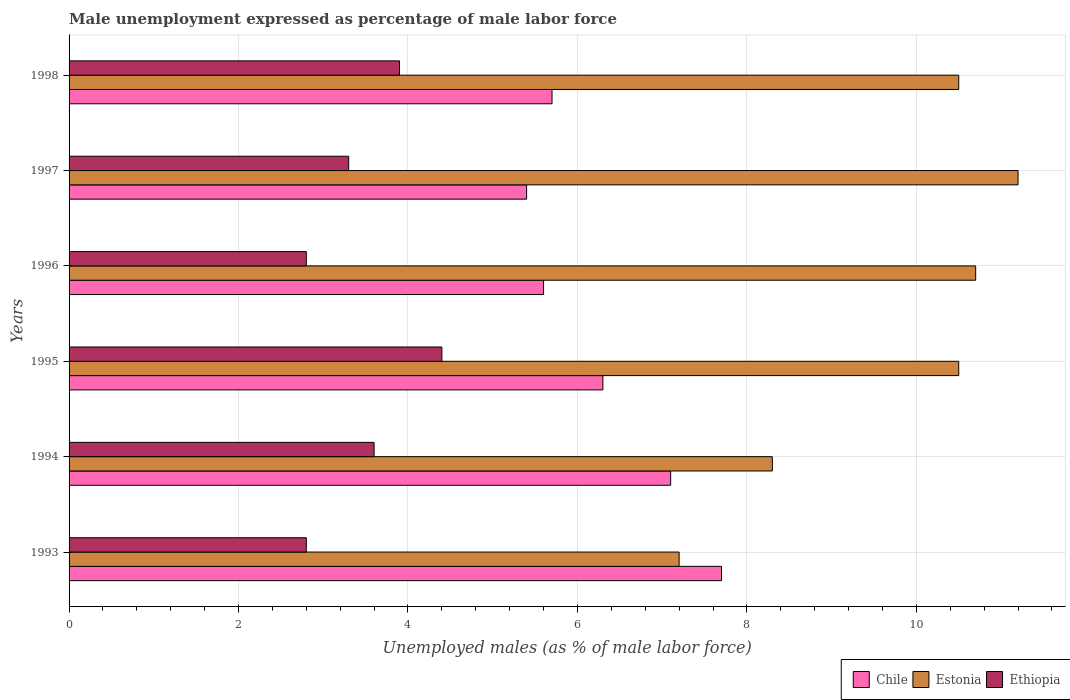How many groups of bars are there?
Your answer should be very brief. 6. Are the number of bars per tick equal to the number of legend labels?
Your answer should be compact. Yes. What is the label of the 1st group of bars from the top?
Provide a short and direct response. 1998. What is the unemployment in males in in Ethiopia in 1997?
Your response must be concise. 3.3. Across all years, what is the maximum unemployment in males in in Chile?
Offer a terse response. 7.7. Across all years, what is the minimum unemployment in males in in Estonia?
Offer a very short reply. 7.2. In which year was the unemployment in males in in Estonia maximum?
Provide a short and direct response. 1997. What is the total unemployment in males in in Estonia in the graph?
Your answer should be very brief. 58.4. What is the difference between the unemployment in males in in Ethiopia in 1995 and that in 1997?
Provide a short and direct response. 1.1. What is the difference between the unemployment in males in in Ethiopia in 1995 and the unemployment in males in in Chile in 1997?
Keep it short and to the point. -1. What is the average unemployment in males in in Estonia per year?
Provide a short and direct response. 9.73. In the year 1996, what is the difference between the unemployment in males in in Chile and unemployment in males in in Ethiopia?
Your response must be concise. 2.8. In how many years, is the unemployment in males in in Ethiopia greater than 1.6 %?
Provide a succinct answer. 6. What is the ratio of the unemployment in males in in Chile in 1997 to that in 1998?
Offer a terse response. 0.95. Is the unemployment in males in in Chile in 1994 less than that in 1997?
Offer a very short reply. No. What is the difference between the highest and the lowest unemployment in males in in Ethiopia?
Offer a very short reply. 1.6. In how many years, is the unemployment in males in in Estonia greater than the average unemployment in males in in Estonia taken over all years?
Offer a terse response. 4. What does the 3rd bar from the top in 1997 represents?
Ensure brevity in your answer.  Chile. What does the 3rd bar from the bottom in 1998 represents?
Your response must be concise. Ethiopia. Is it the case that in every year, the sum of the unemployment in males in in Estonia and unemployment in males in in Ethiopia is greater than the unemployment in males in in Chile?
Keep it short and to the point. Yes. How many bars are there?
Give a very brief answer. 18. Are the values on the major ticks of X-axis written in scientific E-notation?
Make the answer very short. No. Where does the legend appear in the graph?
Your answer should be compact. Bottom right. What is the title of the graph?
Your response must be concise. Male unemployment expressed as percentage of male labor force. Does "Greenland" appear as one of the legend labels in the graph?
Your response must be concise. No. What is the label or title of the X-axis?
Give a very brief answer. Unemployed males (as % of male labor force). What is the label or title of the Y-axis?
Give a very brief answer. Years. What is the Unemployed males (as % of male labor force) of Chile in 1993?
Your answer should be very brief. 7.7. What is the Unemployed males (as % of male labor force) of Estonia in 1993?
Your answer should be compact. 7.2. What is the Unemployed males (as % of male labor force) in Ethiopia in 1993?
Your response must be concise. 2.8. What is the Unemployed males (as % of male labor force) in Chile in 1994?
Your response must be concise. 7.1. What is the Unemployed males (as % of male labor force) of Estonia in 1994?
Offer a very short reply. 8.3. What is the Unemployed males (as % of male labor force) in Ethiopia in 1994?
Provide a short and direct response. 3.6. What is the Unemployed males (as % of male labor force) in Chile in 1995?
Ensure brevity in your answer.  6.3. What is the Unemployed males (as % of male labor force) in Ethiopia in 1995?
Your response must be concise. 4.4. What is the Unemployed males (as % of male labor force) in Chile in 1996?
Ensure brevity in your answer.  5.6. What is the Unemployed males (as % of male labor force) in Estonia in 1996?
Provide a succinct answer. 10.7. What is the Unemployed males (as % of male labor force) in Ethiopia in 1996?
Ensure brevity in your answer.  2.8. What is the Unemployed males (as % of male labor force) in Chile in 1997?
Give a very brief answer. 5.4. What is the Unemployed males (as % of male labor force) in Estonia in 1997?
Your answer should be very brief. 11.2. What is the Unemployed males (as % of male labor force) in Ethiopia in 1997?
Make the answer very short. 3.3. What is the Unemployed males (as % of male labor force) of Chile in 1998?
Provide a short and direct response. 5.7. What is the Unemployed males (as % of male labor force) of Ethiopia in 1998?
Your answer should be compact. 3.9. Across all years, what is the maximum Unemployed males (as % of male labor force) in Chile?
Your answer should be compact. 7.7. Across all years, what is the maximum Unemployed males (as % of male labor force) in Estonia?
Your answer should be compact. 11.2. Across all years, what is the maximum Unemployed males (as % of male labor force) in Ethiopia?
Keep it short and to the point. 4.4. Across all years, what is the minimum Unemployed males (as % of male labor force) in Chile?
Ensure brevity in your answer.  5.4. Across all years, what is the minimum Unemployed males (as % of male labor force) of Estonia?
Your answer should be very brief. 7.2. Across all years, what is the minimum Unemployed males (as % of male labor force) in Ethiopia?
Provide a short and direct response. 2.8. What is the total Unemployed males (as % of male labor force) of Chile in the graph?
Offer a very short reply. 37.8. What is the total Unemployed males (as % of male labor force) in Estonia in the graph?
Ensure brevity in your answer.  58.4. What is the total Unemployed males (as % of male labor force) of Ethiopia in the graph?
Your response must be concise. 20.8. What is the difference between the Unemployed males (as % of male labor force) in Ethiopia in 1993 and that in 1994?
Offer a very short reply. -0.8. What is the difference between the Unemployed males (as % of male labor force) in Chile in 1993 and that in 1995?
Ensure brevity in your answer.  1.4. What is the difference between the Unemployed males (as % of male labor force) of Estonia in 1993 and that in 1995?
Offer a terse response. -3.3. What is the difference between the Unemployed males (as % of male labor force) of Estonia in 1993 and that in 1996?
Give a very brief answer. -3.5. What is the difference between the Unemployed males (as % of male labor force) of Ethiopia in 1993 and that in 1997?
Make the answer very short. -0.5. What is the difference between the Unemployed males (as % of male labor force) in Ethiopia in 1993 and that in 1998?
Offer a terse response. -1.1. What is the difference between the Unemployed males (as % of male labor force) in Estonia in 1994 and that in 1995?
Offer a terse response. -2.2. What is the difference between the Unemployed males (as % of male labor force) in Ethiopia in 1994 and that in 1996?
Provide a succinct answer. 0.8. What is the difference between the Unemployed males (as % of male labor force) of Estonia in 1994 and that in 1997?
Offer a very short reply. -2.9. What is the difference between the Unemployed males (as % of male labor force) in Estonia in 1994 and that in 1998?
Your answer should be compact. -2.2. What is the difference between the Unemployed males (as % of male labor force) of Ethiopia in 1994 and that in 1998?
Make the answer very short. -0.3. What is the difference between the Unemployed males (as % of male labor force) of Chile in 1995 and that in 1996?
Offer a terse response. 0.7. What is the difference between the Unemployed males (as % of male labor force) in Estonia in 1995 and that in 1996?
Make the answer very short. -0.2. What is the difference between the Unemployed males (as % of male labor force) of Ethiopia in 1995 and that in 1996?
Your answer should be very brief. 1.6. What is the difference between the Unemployed males (as % of male labor force) of Chile in 1995 and that in 1997?
Provide a short and direct response. 0.9. What is the difference between the Unemployed males (as % of male labor force) of Estonia in 1995 and that in 1997?
Give a very brief answer. -0.7. What is the difference between the Unemployed males (as % of male labor force) in Ethiopia in 1995 and that in 1997?
Your answer should be compact. 1.1. What is the difference between the Unemployed males (as % of male labor force) in Chile in 1995 and that in 1998?
Keep it short and to the point. 0.6. What is the difference between the Unemployed males (as % of male labor force) in Estonia in 1995 and that in 1998?
Make the answer very short. 0. What is the difference between the Unemployed males (as % of male labor force) in Chile in 1996 and that in 1997?
Offer a terse response. 0.2. What is the difference between the Unemployed males (as % of male labor force) in Ethiopia in 1996 and that in 1997?
Provide a short and direct response. -0.5. What is the difference between the Unemployed males (as % of male labor force) of Chile in 1996 and that in 1998?
Your response must be concise. -0.1. What is the difference between the Unemployed males (as % of male labor force) in Ethiopia in 1996 and that in 1998?
Ensure brevity in your answer.  -1.1. What is the difference between the Unemployed males (as % of male labor force) in Chile in 1997 and that in 1998?
Your answer should be very brief. -0.3. What is the difference between the Unemployed males (as % of male labor force) in Estonia in 1993 and the Unemployed males (as % of male labor force) in Ethiopia in 1994?
Provide a short and direct response. 3.6. What is the difference between the Unemployed males (as % of male labor force) in Chile in 1993 and the Unemployed males (as % of male labor force) in Ethiopia in 1995?
Offer a terse response. 3.3. What is the difference between the Unemployed males (as % of male labor force) of Estonia in 1993 and the Unemployed males (as % of male labor force) of Ethiopia in 1995?
Your answer should be compact. 2.8. What is the difference between the Unemployed males (as % of male labor force) in Estonia in 1993 and the Unemployed males (as % of male labor force) in Ethiopia in 1997?
Keep it short and to the point. 3.9. What is the difference between the Unemployed males (as % of male labor force) of Chile in 1993 and the Unemployed males (as % of male labor force) of Ethiopia in 1998?
Offer a terse response. 3.8. What is the difference between the Unemployed males (as % of male labor force) of Chile in 1994 and the Unemployed males (as % of male labor force) of Estonia in 1995?
Your answer should be compact. -3.4. What is the difference between the Unemployed males (as % of male labor force) of Chile in 1994 and the Unemployed males (as % of male labor force) of Ethiopia in 1996?
Provide a short and direct response. 4.3. What is the difference between the Unemployed males (as % of male labor force) of Estonia in 1994 and the Unemployed males (as % of male labor force) of Ethiopia in 1996?
Offer a very short reply. 5.5. What is the difference between the Unemployed males (as % of male labor force) in Chile in 1994 and the Unemployed males (as % of male labor force) in Estonia in 1998?
Offer a very short reply. -3.4. What is the difference between the Unemployed males (as % of male labor force) of Chile in 1994 and the Unemployed males (as % of male labor force) of Ethiopia in 1998?
Your answer should be compact. 3.2. What is the difference between the Unemployed males (as % of male labor force) of Estonia in 1994 and the Unemployed males (as % of male labor force) of Ethiopia in 1998?
Keep it short and to the point. 4.4. What is the difference between the Unemployed males (as % of male labor force) in Chile in 1995 and the Unemployed males (as % of male labor force) in Estonia in 1996?
Make the answer very short. -4.4. What is the difference between the Unemployed males (as % of male labor force) in Estonia in 1995 and the Unemployed males (as % of male labor force) in Ethiopia in 1996?
Provide a short and direct response. 7.7. What is the difference between the Unemployed males (as % of male labor force) of Chile in 1995 and the Unemployed males (as % of male labor force) of Ethiopia in 1997?
Provide a succinct answer. 3. What is the difference between the Unemployed males (as % of male labor force) of Estonia in 1995 and the Unemployed males (as % of male labor force) of Ethiopia in 1997?
Offer a terse response. 7.2. What is the difference between the Unemployed males (as % of male labor force) of Chile in 1995 and the Unemployed males (as % of male labor force) of Ethiopia in 1998?
Offer a very short reply. 2.4. What is the difference between the Unemployed males (as % of male labor force) in Estonia in 1995 and the Unemployed males (as % of male labor force) in Ethiopia in 1998?
Keep it short and to the point. 6.6. What is the difference between the Unemployed males (as % of male labor force) in Chile in 1996 and the Unemployed males (as % of male labor force) in Estonia in 1997?
Ensure brevity in your answer.  -5.6. What is the difference between the Unemployed males (as % of male labor force) in Chile in 1996 and the Unemployed males (as % of male labor force) in Ethiopia in 1997?
Keep it short and to the point. 2.3. What is the difference between the Unemployed males (as % of male labor force) in Estonia in 1996 and the Unemployed males (as % of male labor force) in Ethiopia in 1997?
Your answer should be very brief. 7.4. What is the difference between the Unemployed males (as % of male labor force) of Chile in 1996 and the Unemployed males (as % of male labor force) of Estonia in 1998?
Offer a very short reply. -4.9. What is the difference between the Unemployed males (as % of male labor force) of Estonia in 1996 and the Unemployed males (as % of male labor force) of Ethiopia in 1998?
Offer a very short reply. 6.8. What is the difference between the Unemployed males (as % of male labor force) of Estonia in 1997 and the Unemployed males (as % of male labor force) of Ethiopia in 1998?
Ensure brevity in your answer.  7.3. What is the average Unemployed males (as % of male labor force) in Estonia per year?
Keep it short and to the point. 9.73. What is the average Unemployed males (as % of male labor force) of Ethiopia per year?
Your answer should be compact. 3.47. In the year 1993, what is the difference between the Unemployed males (as % of male labor force) of Chile and Unemployed males (as % of male labor force) of Estonia?
Provide a succinct answer. 0.5. In the year 1994, what is the difference between the Unemployed males (as % of male labor force) in Chile and Unemployed males (as % of male labor force) in Estonia?
Offer a terse response. -1.2. In the year 1994, what is the difference between the Unemployed males (as % of male labor force) of Chile and Unemployed males (as % of male labor force) of Ethiopia?
Keep it short and to the point. 3.5. In the year 1995, what is the difference between the Unemployed males (as % of male labor force) in Chile and Unemployed males (as % of male labor force) in Ethiopia?
Your answer should be compact. 1.9. In the year 1995, what is the difference between the Unemployed males (as % of male labor force) of Estonia and Unemployed males (as % of male labor force) of Ethiopia?
Your response must be concise. 6.1. In the year 1996, what is the difference between the Unemployed males (as % of male labor force) in Estonia and Unemployed males (as % of male labor force) in Ethiopia?
Your answer should be very brief. 7.9. In the year 1997, what is the difference between the Unemployed males (as % of male labor force) of Chile and Unemployed males (as % of male labor force) of Estonia?
Offer a very short reply. -5.8. In the year 1997, what is the difference between the Unemployed males (as % of male labor force) in Estonia and Unemployed males (as % of male labor force) in Ethiopia?
Your answer should be compact. 7.9. In the year 1998, what is the difference between the Unemployed males (as % of male labor force) in Chile and Unemployed males (as % of male labor force) in Estonia?
Your answer should be very brief. -4.8. In the year 1998, what is the difference between the Unemployed males (as % of male labor force) of Estonia and Unemployed males (as % of male labor force) of Ethiopia?
Your answer should be compact. 6.6. What is the ratio of the Unemployed males (as % of male labor force) in Chile in 1993 to that in 1994?
Your answer should be very brief. 1.08. What is the ratio of the Unemployed males (as % of male labor force) of Estonia in 1993 to that in 1994?
Your response must be concise. 0.87. What is the ratio of the Unemployed males (as % of male labor force) of Ethiopia in 1993 to that in 1994?
Keep it short and to the point. 0.78. What is the ratio of the Unemployed males (as % of male labor force) in Chile in 1993 to that in 1995?
Provide a succinct answer. 1.22. What is the ratio of the Unemployed males (as % of male labor force) of Estonia in 1993 to that in 1995?
Keep it short and to the point. 0.69. What is the ratio of the Unemployed males (as % of male labor force) of Ethiopia in 1993 to that in 1995?
Your answer should be compact. 0.64. What is the ratio of the Unemployed males (as % of male labor force) in Chile in 1993 to that in 1996?
Your answer should be compact. 1.38. What is the ratio of the Unemployed males (as % of male labor force) of Estonia in 1993 to that in 1996?
Keep it short and to the point. 0.67. What is the ratio of the Unemployed males (as % of male labor force) of Ethiopia in 1993 to that in 1996?
Your answer should be very brief. 1. What is the ratio of the Unemployed males (as % of male labor force) of Chile in 1993 to that in 1997?
Your answer should be very brief. 1.43. What is the ratio of the Unemployed males (as % of male labor force) in Estonia in 1993 to that in 1997?
Your response must be concise. 0.64. What is the ratio of the Unemployed males (as % of male labor force) of Ethiopia in 1993 to that in 1997?
Give a very brief answer. 0.85. What is the ratio of the Unemployed males (as % of male labor force) of Chile in 1993 to that in 1998?
Provide a short and direct response. 1.35. What is the ratio of the Unemployed males (as % of male labor force) of Estonia in 1993 to that in 1998?
Give a very brief answer. 0.69. What is the ratio of the Unemployed males (as % of male labor force) of Ethiopia in 1993 to that in 1998?
Offer a very short reply. 0.72. What is the ratio of the Unemployed males (as % of male labor force) of Chile in 1994 to that in 1995?
Provide a succinct answer. 1.13. What is the ratio of the Unemployed males (as % of male labor force) of Estonia in 1994 to that in 1995?
Provide a short and direct response. 0.79. What is the ratio of the Unemployed males (as % of male labor force) of Ethiopia in 1994 to that in 1995?
Provide a succinct answer. 0.82. What is the ratio of the Unemployed males (as % of male labor force) of Chile in 1994 to that in 1996?
Offer a terse response. 1.27. What is the ratio of the Unemployed males (as % of male labor force) in Estonia in 1994 to that in 1996?
Provide a short and direct response. 0.78. What is the ratio of the Unemployed males (as % of male labor force) in Chile in 1994 to that in 1997?
Your answer should be compact. 1.31. What is the ratio of the Unemployed males (as % of male labor force) in Estonia in 1994 to that in 1997?
Make the answer very short. 0.74. What is the ratio of the Unemployed males (as % of male labor force) of Ethiopia in 1994 to that in 1997?
Offer a terse response. 1.09. What is the ratio of the Unemployed males (as % of male labor force) in Chile in 1994 to that in 1998?
Offer a terse response. 1.25. What is the ratio of the Unemployed males (as % of male labor force) in Estonia in 1994 to that in 1998?
Give a very brief answer. 0.79. What is the ratio of the Unemployed males (as % of male labor force) in Estonia in 1995 to that in 1996?
Offer a very short reply. 0.98. What is the ratio of the Unemployed males (as % of male labor force) in Ethiopia in 1995 to that in 1996?
Provide a succinct answer. 1.57. What is the ratio of the Unemployed males (as % of male labor force) in Chile in 1995 to that in 1997?
Give a very brief answer. 1.17. What is the ratio of the Unemployed males (as % of male labor force) in Estonia in 1995 to that in 1997?
Ensure brevity in your answer.  0.94. What is the ratio of the Unemployed males (as % of male labor force) in Chile in 1995 to that in 1998?
Your answer should be compact. 1.11. What is the ratio of the Unemployed males (as % of male labor force) in Ethiopia in 1995 to that in 1998?
Provide a succinct answer. 1.13. What is the ratio of the Unemployed males (as % of male labor force) of Estonia in 1996 to that in 1997?
Your answer should be compact. 0.96. What is the ratio of the Unemployed males (as % of male labor force) of Ethiopia in 1996 to that in 1997?
Offer a very short reply. 0.85. What is the ratio of the Unemployed males (as % of male labor force) in Chile in 1996 to that in 1998?
Your answer should be compact. 0.98. What is the ratio of the Unemployed males (as % of male labor force) of Ethiopia in 1996 to that in 1998?
Ensure brevity in your answer.  0.72. What is the ratio of the Unemployed males (as % of male labor force) in Chile in 1997 to that in 1998?
Offer a terse response. 0.95. What is the ratio of the Unemployed males (as % of male labor force) in Estonia in 1997 to that in 1998?
Offer a very short reply. 1.07. What is the ratio of the Unemployed males (as % of male labor force) in Ethiopia in 1997 to that in 1998?
Your answer should be very brief. 0.85. What is the difference between the highest and the lowest Unemployed males (as % of male labor force) in Chile?
Make the answer very short. 2.3. What is the difference between the highest and the lowest Unemployed males (as % of male labor force) in Estonia?
Offer a terse response. 4. 